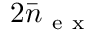Convert formula to latex. <formula><loc_0><loc_0><loc_500><loc_500>2 \bar { n } _ { e x }</formula> 